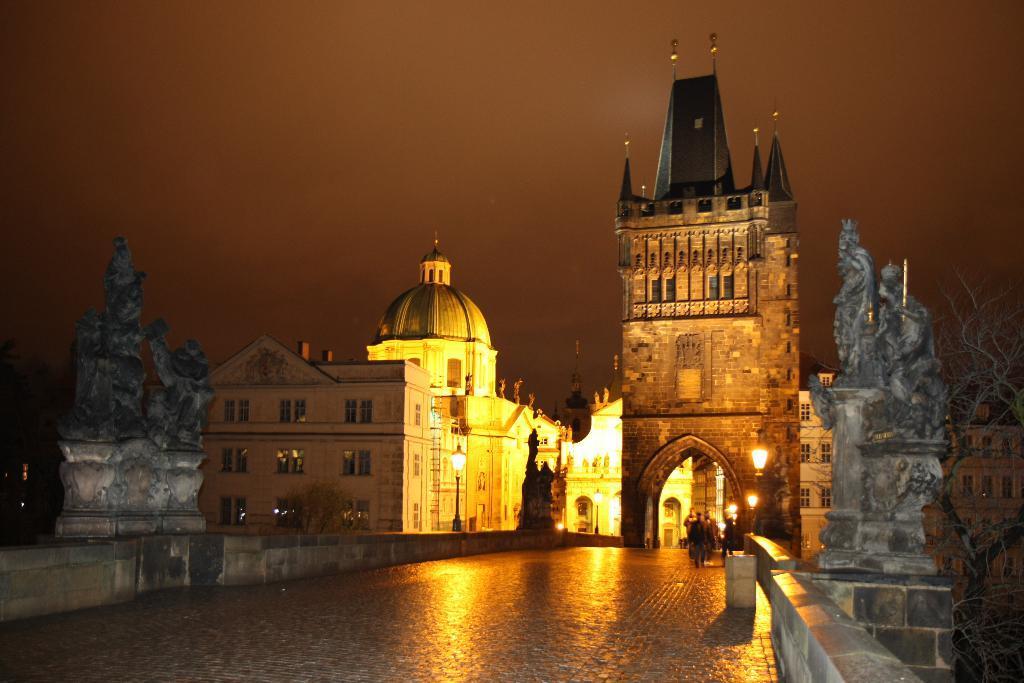Describe this image in one or two sentences. In this image I can see a fort , in front of the fort I can see person and lights and sculpture and the wall and at the top I can see the sky and on the right side I can see a tree and this picture is taken during night. 